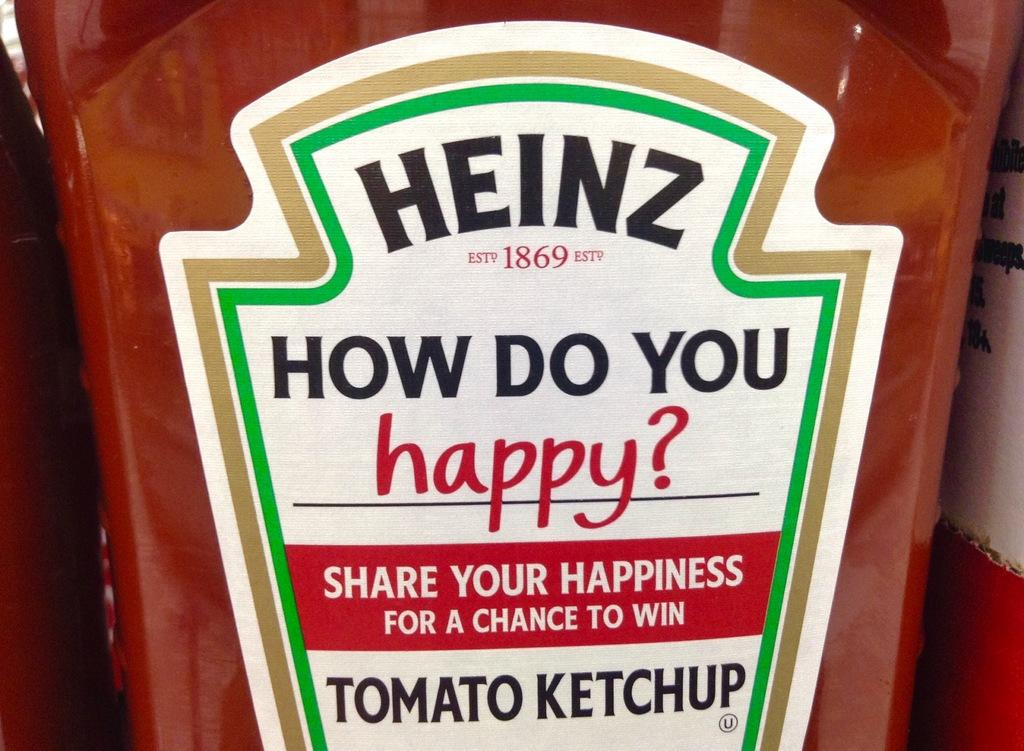What is the main object in the image? There is a tomato ketchup bottle in the image. What is on the tomato ketchup bottle? There is a sticker on the tomato ketchup bottle. What does the sticker say? The sticker has the text "how do you happy" on it. Is the tomato ketchup bottle poisonous in the image? No, there is no indication that the tomato ketchup bottle is poisonous in the image. Is there a fight happening between the tomato ketchup bottle and the sticker? No, there is no fight depicted in the image; it simply shows a tomato ketchup bottle with a sticker on it. 